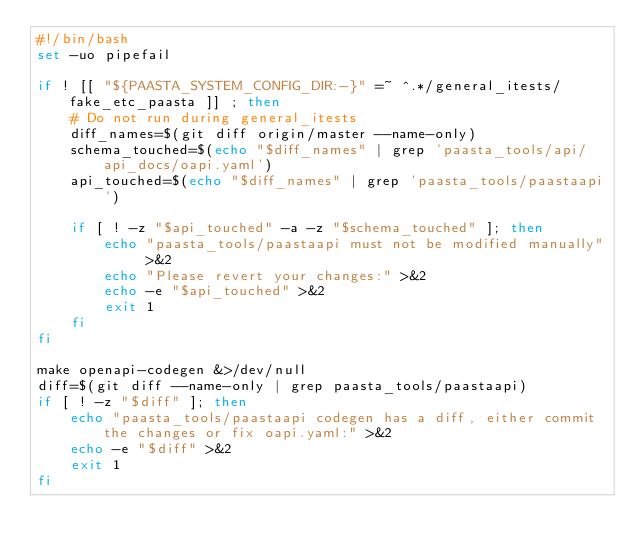<code> <loc_0><loc_0><loc_500><loc_500><_Bash_>#!/bin/bash
set -uo pipefail

if ! [[ "${PAASTA_SYSTEM_CONFIG_DIR:-}" =~ ^.*/general_itests/fake_etc_paasta ]] ; then
    # Do not run during general_itests
    diff_names=$(git diff origin/master --name-only)
    schema_touched=$(echo "$diff_names" | grep 'paasta_tools/api/api_docs/oapi.yaml')
    api_touched=$(echo "$diff_names" | grep 'paasta_tools/paastaapi')

    if [ ! -z "$api_touched" -a -z "$schema_touched" ]; then
        echo "paasta_tools/paastaapi must not be modified manually" >&2
        echo "Please revert your changes:" >&2
        echo -e "$api_touched" >&2
        exit 1
    fi
fi

make openapi-codegen &>/dev/null
diff=$(git diff --name-only | grep paasta_tools/paastaapi)
if [ ! -z "$diff" ]; then
    echo "paasta_tools/paastaapi codegen has a diff, either commit the changes or fix oapi.yaml:" >&2
    echo -e "$diff" >&2
    exit 1
fi
</code> 